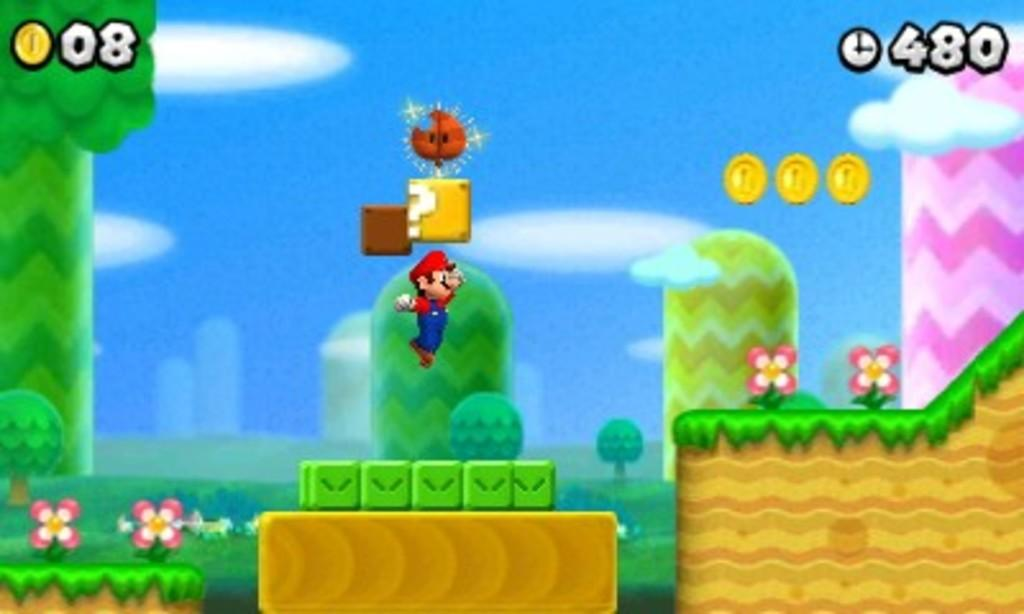What type of image is shown in the screenshot? The image appears to be a video game screenshot. How many bears can be seen stitching in the sun in the image? There are no bears or stitching activities visible in the image, as it is a video game screenshot. 